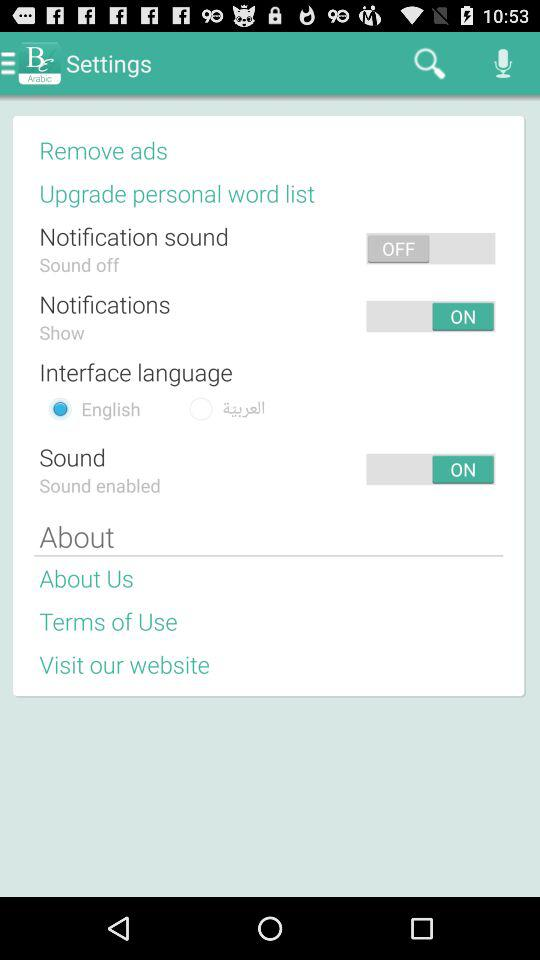How many languages are available for the interface?
Answer the question using a single word or phrase. 2 